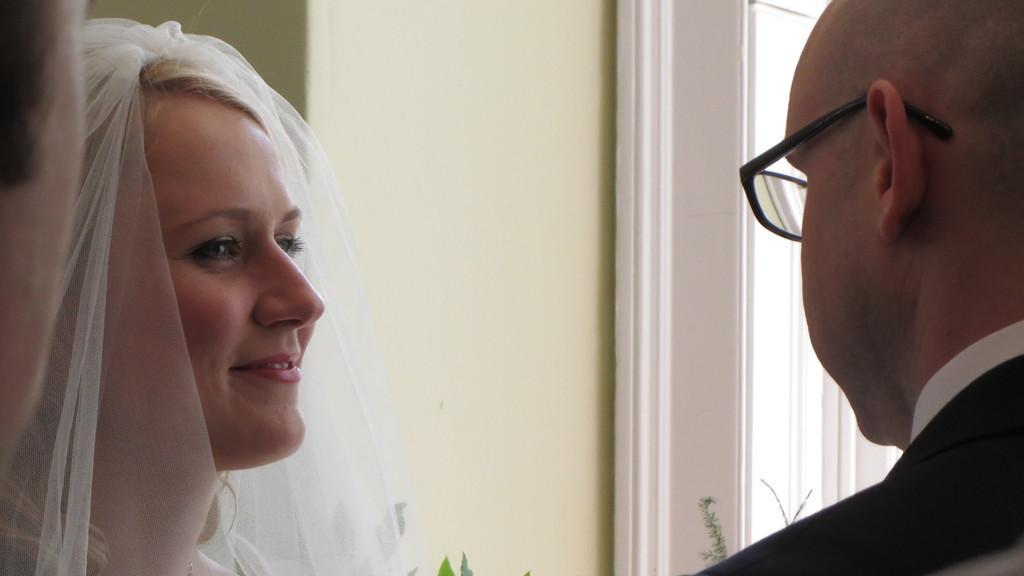Could you give a brief overview of what you see in this image? In this image there is a woman on the left side who is looking at the man who is in front of her. In the background there is a wall. At the bottom there are plants. On the left side there is another person. 